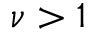Convert formula to latex. <formula><loc_0><loc_0><loc_500><loc_500>\nu > 1</formula> 